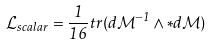Convert formula to latex. <formula><loc_0><loc_0><loc_500><loc_500>\mathcal { L } _ { s c a l a r } = \frac { 1 } { 1 6 } t r ( d \mathcal { M } ^ { - 1 } \wedge \ast d \mathcal { M } )</formula> 